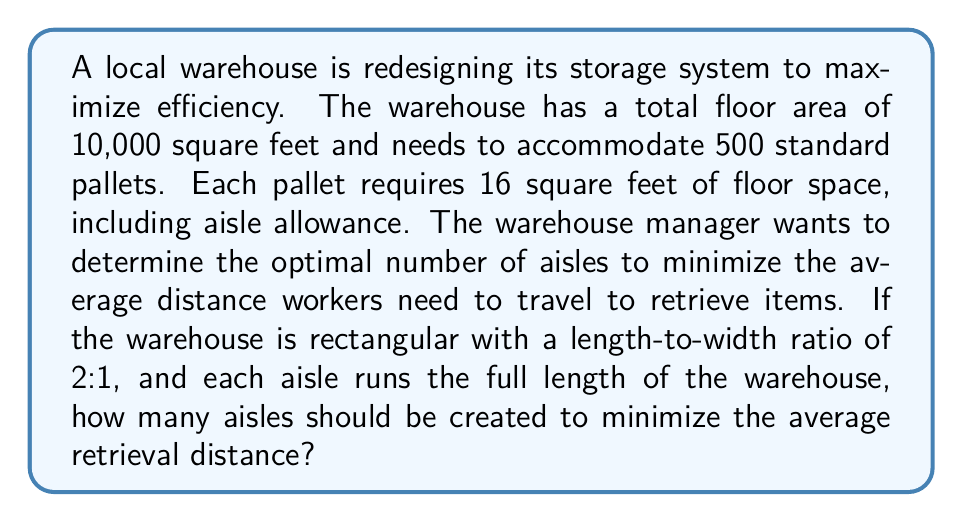Provide a solution to this math problem. Let's approach this problem step-by-step:

1) First, we need to calculate the dimensions of the warehouse:
   If the area is 10,000 sq ft and the length-to-width ratio is 2:1, then:
   $$ L \times W = 10,000 $$
   $$ L = 2W $$
   $$ 2W \times W = 10,000 $$
   $$ 2W^2 = 10,000 $$
   $$ W^2 = 5,000 $$
   $$ W = \sqrt{5,000} \approx 70.71 \text{ ft} $$
   $$ L = 2W \approx 141.42 \text{ ft} $$

2) The total area occupied by pallets:
   $$ 500 \text{ pallets} \times 16 \text{ sq ft/pallet} = 8,000 \text{ sq ft} $$

3) The remaining area for aisles:
   $$ 10,000 \text{ sq ft} - 8,000 \text{ sq ft} = 2,000 \text{ sq ft} $$

4) If we have $n$ aisles, each aisle will have a width of:
   $$ \text{Aisle Width} = \frac{2,000 \text{ sq ft}}{n \times 141.42 \text{ ft}} = \frac{14.14}{n} \text{ ft} $$

5) The average distance to retrieve an item can be approximated by half the width of the storage area plus half the length of an aisle:
   $$ \text{Average Distance} = \frac{1}{2}(70.71 - \frac{14.14}{n}) + \frac{141.42}{2} = 70.71 - \frac{7.07}{n} $$

6) To minimize this distance, we differentiate with respect to $n$ and set it to zero:
   $$ \frac{d}{dn}(70.71 - \frac{7.07}{n}) = \frac{7.07}{n^2} = 0 $$

7) This equation is always positive for positive $n$, indicating that the average distance decreases as $n$ increases. However, we need to consider practical constraints.

8) The minimum aisle width for forklift operation is typically around 12 feet. So, we can solve:
   $$ \frac{14.14}{n} = 12 $$
   $$ n = \frac{14.14}{12} \approx 1.18 $$

9) Since we need a whole number of aisles, we round up to 2 aisles.
Answer: The optimal number of aisles is 2. 